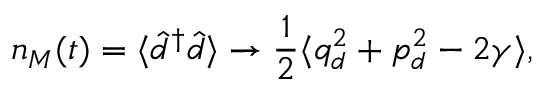<formula> <loc_0><loc_0><loc_500><loc_500>n _ { M } ( t ) = \langle \hat { d } ^ { \dagger } \hat { d } \rangle \to \frac { 1 } { 2 } \langle q _ { d } ^ { 2 } + p _ { d } ^ { 2 } - 2 \gamma \rangle ,</formula> 